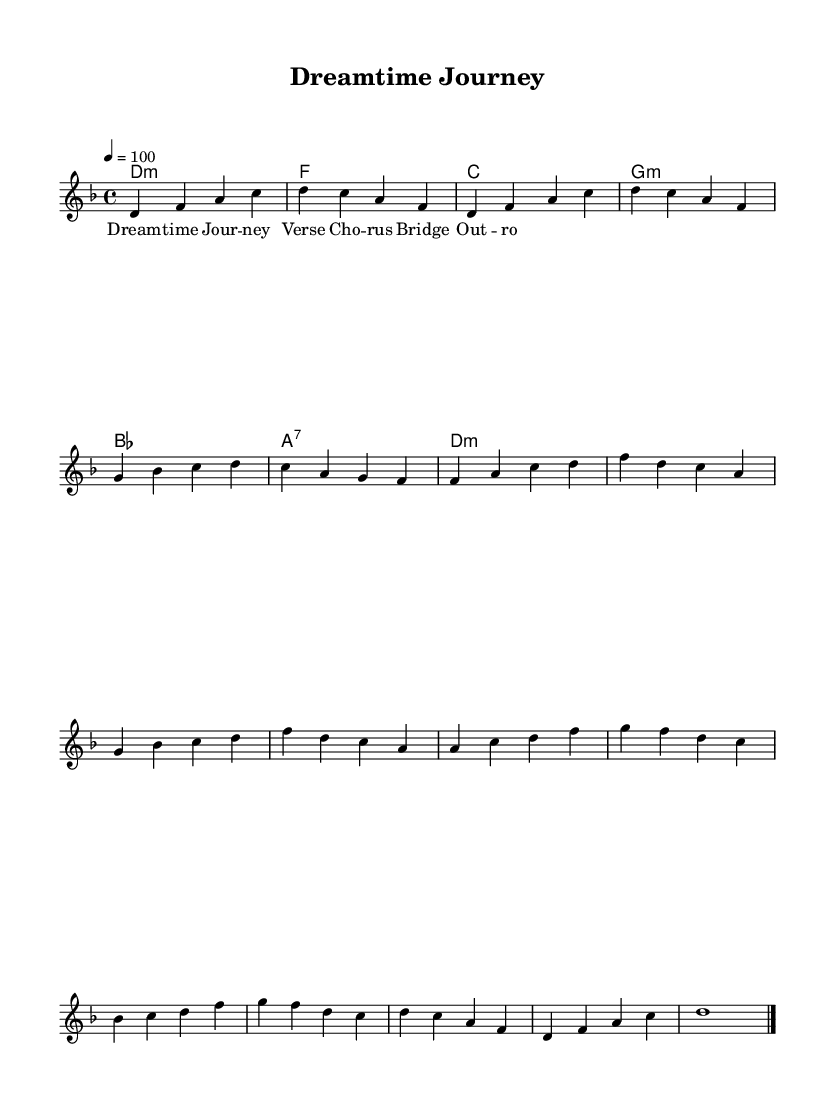What is the key signature of this music? The key signature shown at the beginning of the music indicates it is in D minor, which has one flat.
Answer: D minor What is the time signature of this music? The time signature is displayed at the beginning and indicates that the piece is in 4/4 time, meaning there are four beats per measure.
Answer: 4/4 What is the tempo marking for this piece? The tempo marking indicates a speed of 100 beats per minute, which is expressed as "4 equals 100."
Answer: 100 How many sections are indicated in the melody? The melody includes sections labeled as Intro, Verse, Chorus, Bridge, and Outro, totaling five distinct sections.
Answer: Five What is the first chord in the harmonies? The first chord in the harmonies is labeled as D minor, which corresponds to the tonic of the key indicated.
Answer: D minor What is the main theme of this piece? The title suggests the theme revolves around a "Dreamtime Journey," reflecting the Aboriginal Dreamtime stories set to music.
Answer: Dreamtime Journey Which section follows the Verse in the melody? The melody structure indicates that the Chorus section follows immediately after the Verse, outlining the flow of the music.
Answer: Chorus 